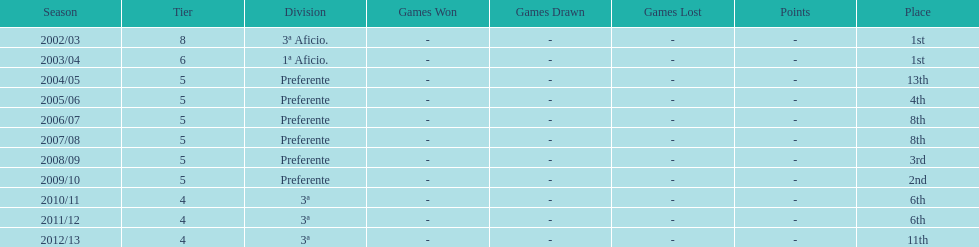How long did the team stay in first place? 2 years. Give me the full table as a dictionary. {'header': ['Season', 'Tier', 'Division', 'Games Won', 'Games Drawn', 'Games Lost', 'Points', 'Place'], 'rows': [['2002/03', '8', '3ª Aficio.', '-', '-', '-', '-', '1st'], ['2003/04', '6', '1ª Aficio.', '-', '-', '-', '-', '1st'], ['2004/05', '5', 'Preferente', '-', '-', '-', '-', '13th'], ['2005/06', '5', 'Preferente', '-', '-', '-', '-', '4th'], ['2006/07', '5', 'Preferente', '-', '-', '-', '-', '8th'], ['2007/08', '5', 'Preferente', '-', '-', '-', '-', '8th'], ['2008/09', '5', 'Preferente', '-', '-', '-', '-', '3rd'], ['2009/10', '5', 'Preferente', '-', '-', '-', '-', '2nd'], ['2010/11', '4', '3ª', '-', '-', '-', '-', '6th'], ['2011/12', '4', '3ª', '-', '-', '-', '-', '6th'], ['2012/13', '4', '3ª', '-', '-', '-', '-', '11th']]} 